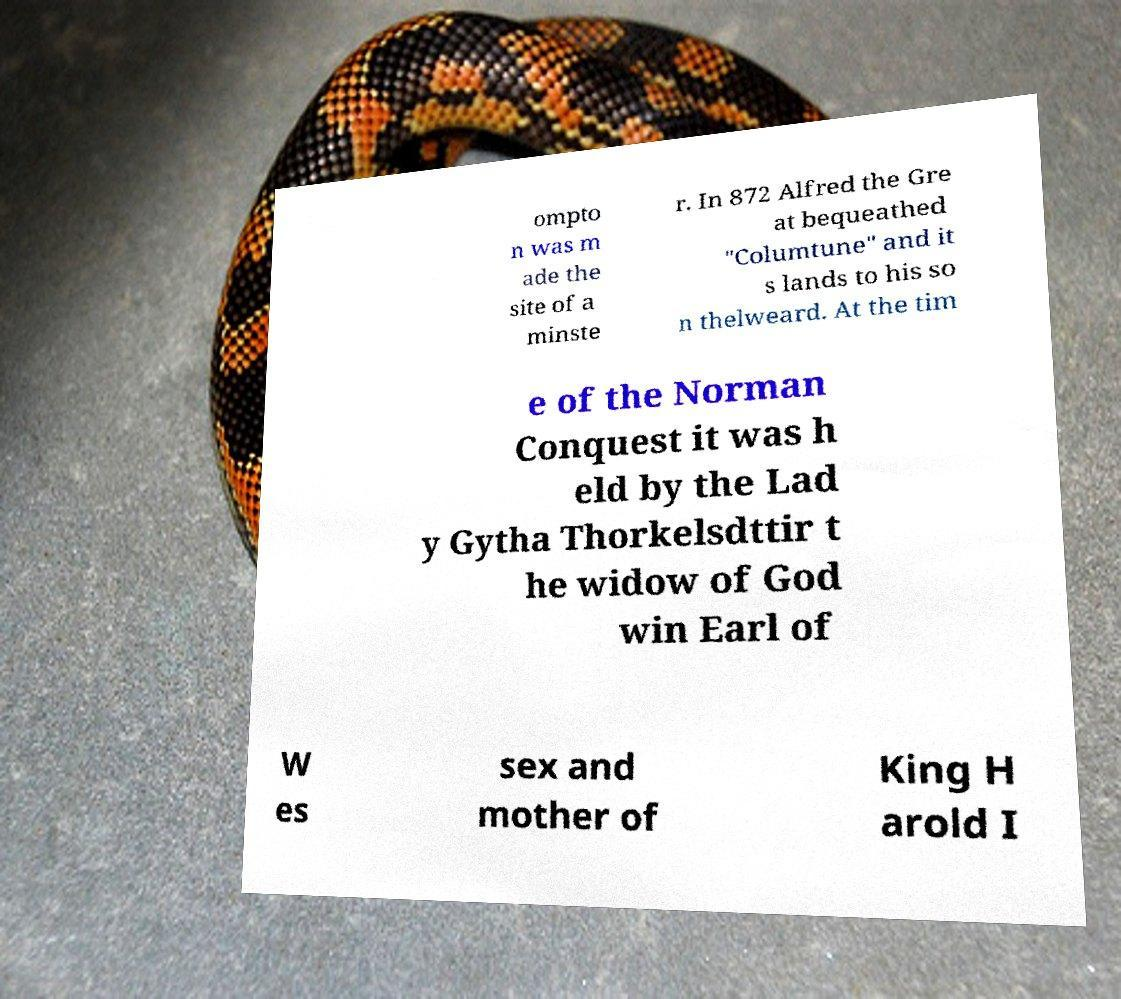What messages or text are displayed in this image? I need them in a readable, typed format. ompto n was m ade the site of a minste r. In 872 Alfred the Gre at bequeathed "Columtune" and it s lands to his so n thelweard. At the tim e of the Norman Conquest it was h eld by the Lad y Gytha Thorkelsdttir t he widow of God win Earl of W es sex and mother of King H arold I 